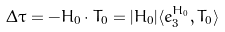Convert formula to latex. <formula><loc_0><loc_0><loc_500><loc_500>\Delta \tau = - H _ { 0 } \cdot T _ { 0 } = | H _ { 0 } | \langle e ^ { H _ { 0 } } _ { 3 } , T _ { 0 } \rangle</formula> 